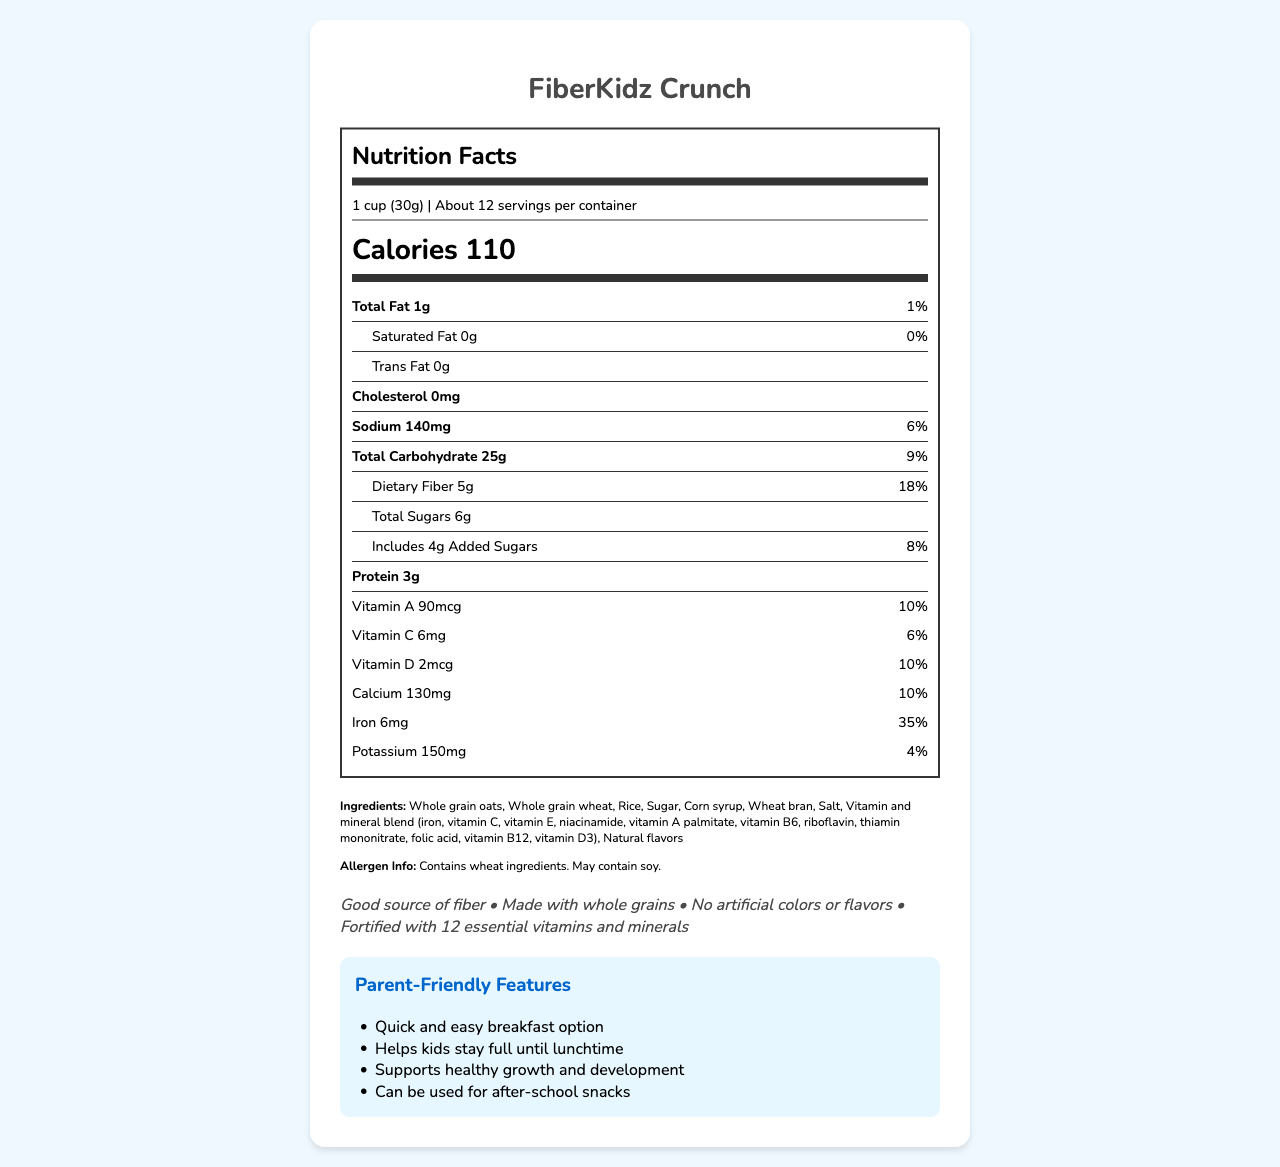what is the name of the breakfast cereal? The name of the cereal is stated at the top of the document and also in the title.
Answer: FiberKidz Crunch how many calories are there per serving? The document explicitly states "Calories 110" in the nutrition label section.
Answer: 110 how much dietary fiber is in one serving? The nutrition label specifies "Dietary Fiber 5g" under the total carbohydrate section.
Answer: 5g how much sodium does one serving contain? The document shows "Sodium 140mg" in the nutrient information section.
Answer: 140mg list two preparation suggestions for this cereal. The preparation suggestions section provides these two steps along with a third optional step about adding fruits.
Answer: Pour 1 cup of cereal into a bowl and add 1/2 cup of low-fat milk. is the cereal a good source of iron? The cereal provides 35% of the daily value for iron, which can be considered a good source.
Answer: Yes how many servings are in each container? A. About 6 B. About 8 C. About 12 D. About 14 The document states "About 12" servings per container in the serving information section.
Answer: C. About 12 which of these vitamins is fortified in the cereal? I. Vitamin A II. Vitamin K III. Vitamin D IV. Vitamin B12 A. I and II B. II and III C. I, III, and IV D. I and IV The document mentions Vitamin A, Vitamin D, and Vitamin B12 with their respective amounts and daily values.
Answer: C. I, III, and IV does the cereal contain any artificial colors or flavors? The health claims section specifically states "No artificial colors or flavors."
Answer: No summarize the key nutritional features of FiberKidz Crunch. The summary incorporates all main nutritional aspects, health claims, and the general benefits of the cereal as presented in the document.
Answer: FiberKidz Crunch is a kid-friendly breakfast cereal that is a good source of fiber, fortified with 12 essential vitamins and minerals, and has no artificial colors or flavors. It is made with whole grains and provides essential nutrients such as iron, Vitamin A, and calcium. Each serving contains 110 calories, 1g total fat, 25g total carbohydrates, and 3g of protein. what are the main ingredients used in FiberKidz Crunch? The ingredients section lists all the main components used in the cereal.
Answer: Whole grain oats, Whole grain wheat, Rice, Sugar, Corn syrup, Wheat bran, Salt, Vitamin and mineral blend, Natural flavors based on the document, how much protein is present in a serving of FiberKidz Crunch? The nutrition label specifies "Protein 3g" under the nutrient information section.
Answer: 3g does the cereal contain soy as an ingredient? The allergen info states that the cereal may contain soy, but it does not confirm it as a direct ingredient.
Answer: Not enough information how much Vitamin B6 does one serving of the cereal contain? The nutrition label specifies "Vitamin B6 0.4mg" detailing the amount and daily value.
Answer: 0.4mg what should you do to maintain the freshness of the cereal? The storage instructions mention resealing the package to maintain freshness.
Answer: Reseal package why would this cereal be suitable for a busy morning routine? The parent-friendly features highlight its suitability for a quick breakfast and its ability to keep kids satiated.
Answer: It is a quick and easy breakfast option that helps kids stay full until lunchtime. 